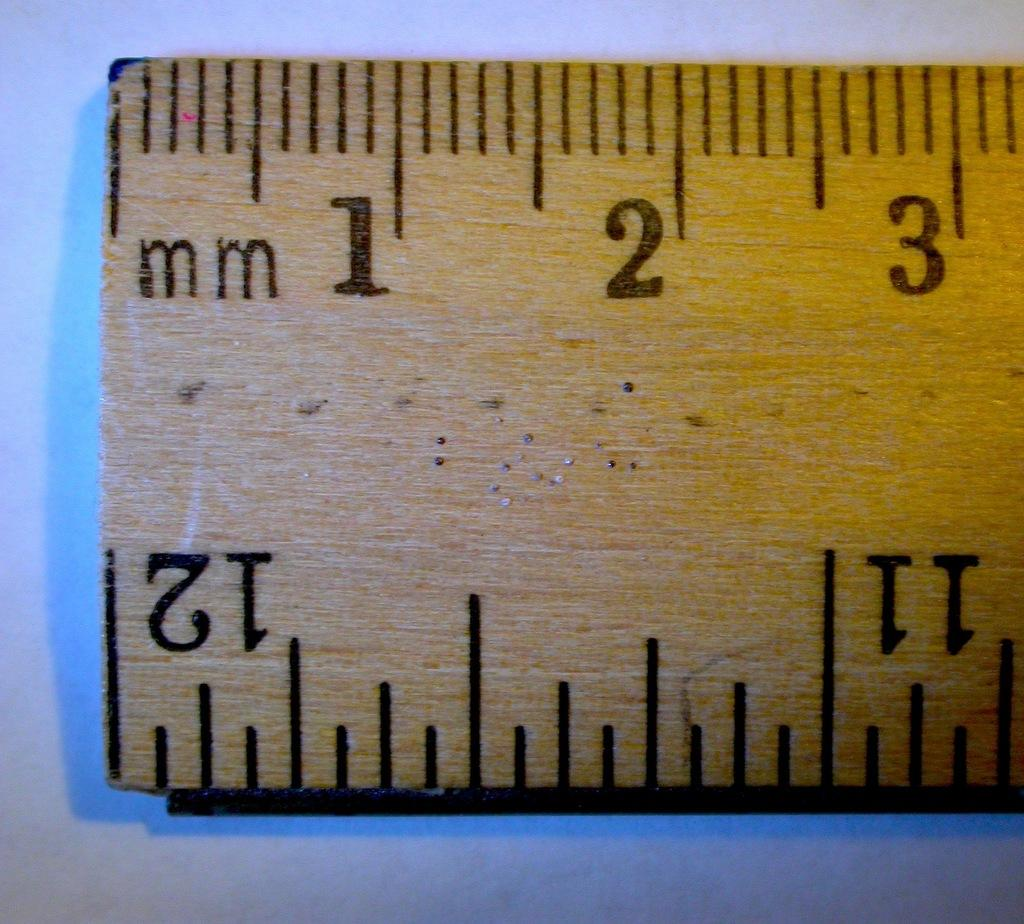<image>
Render a clear and concise summary of the photo. The ruler shows up to three full millimeters and a twelve 